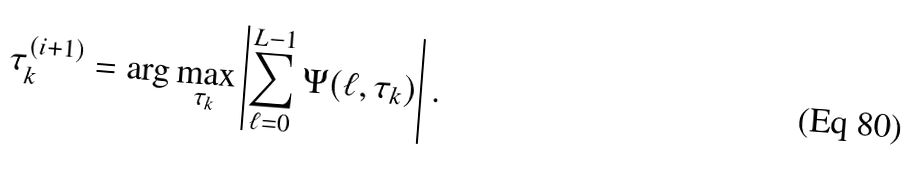<formula> <loc_0><loc_0><loc_500><loc_500>\tau ^ { ( i + 1 ) } _ { k } = \arg \max _ { \tau _ { k } } \left | \sum _ { \ell = 0 } ^ { L - 1 } \Psi ( \ell , \tau _ { k } ) \right | .</formula> 